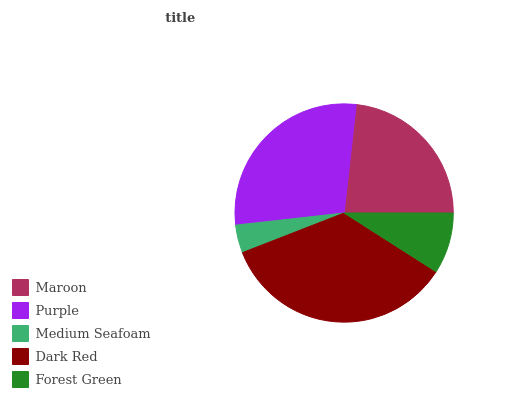Is Medium Seafoam the minimum?
Answer yes or no. Yes. Is Dark Red the maximum?
Answer yes or no. Yes. Is Purple the minimum?
Answer yes or no. No. Is Purple the maximum?
Answer yes or no. No. Is Purple greater than Maroon?
Answer yes or no. Yes. Is Maroon less than Purple?
Answer yes or no. Yes. Is Maroon greater than Purple?
Answer yes or no. No. Is Purple less than Maroon?
Answer yes or no. No. Is Maroon the high median?
Answer yes or no. Yes. Is Maroon the low median?
Answer yes or no. Yes. Is Forest Green the high median?
Answer yes or no. No. Is Forest Green the low median?
Answer yes or no. No. 